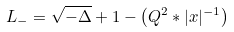Convert formula to latex. <formula><loc_0><loc_0><loc_500><loc_500>L _ { - } = \sqrt { - \Delta } + 1 - \left ( Q ^ { 2 } \ast | x | ^ { - 1 } \right )</formula> 